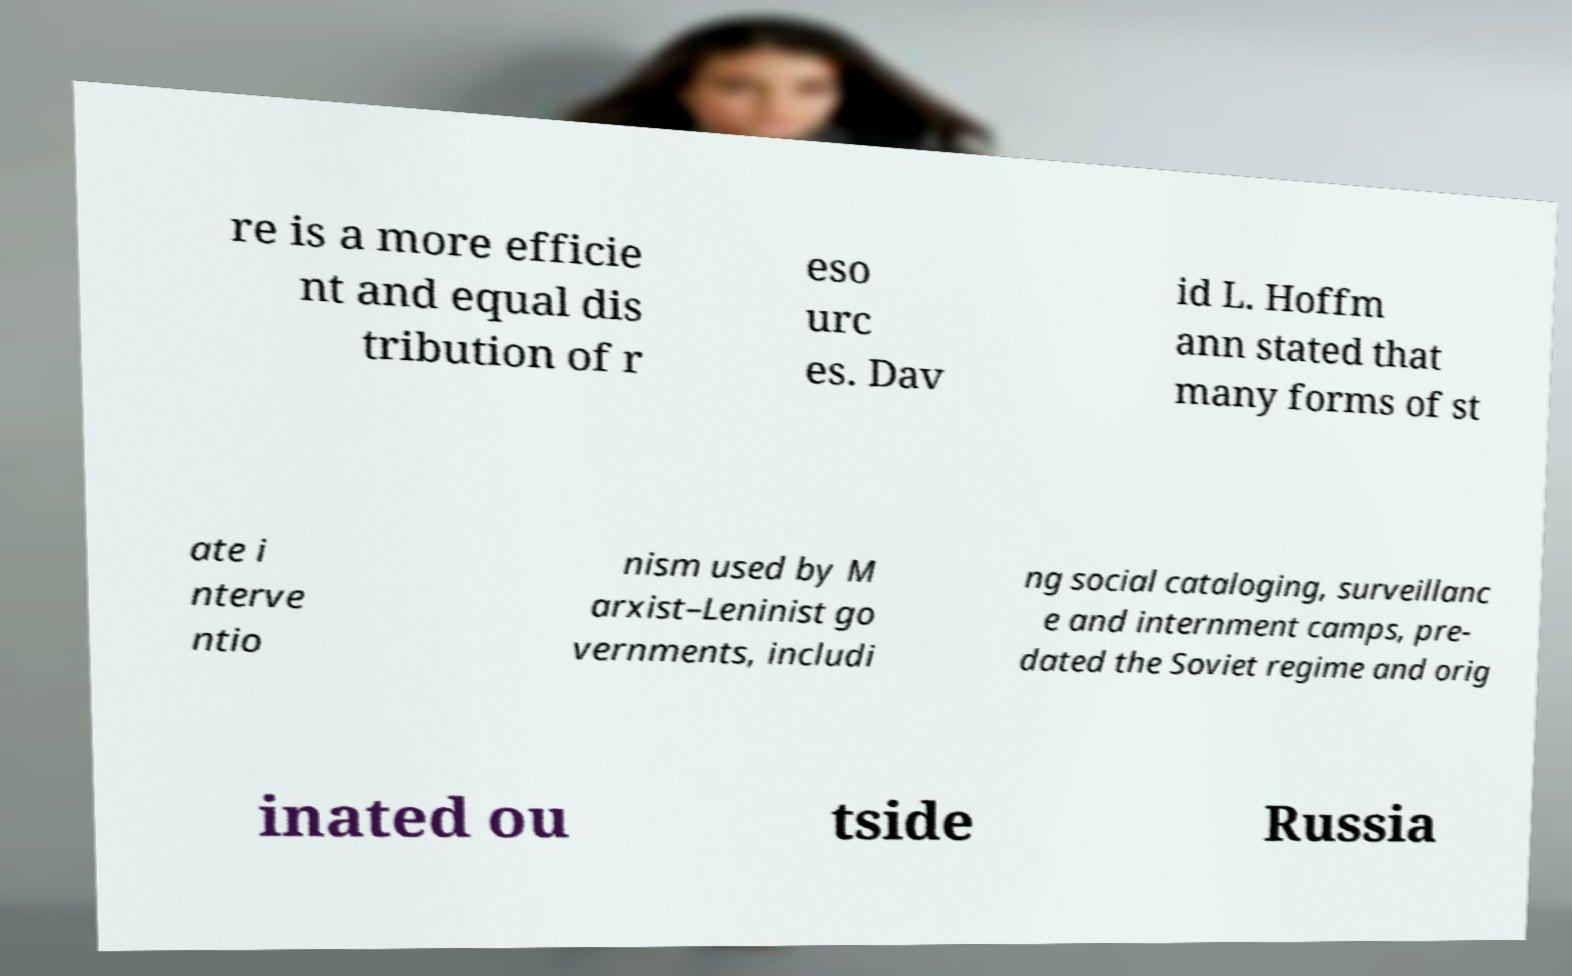Could you assist in decoding the text presented in this image and type it out clearly? re is a more efficie nt and equal dis tribution of r eso urc es. Dav id L. Hoffm ann stated that many forms of st ate i nterve ntio nism used by M arxist–Leninist go vernments, includi ng social cataloging, surveillanc e and internment camps, pre- dated the Soviet regime and orig inated ou tside Russia 